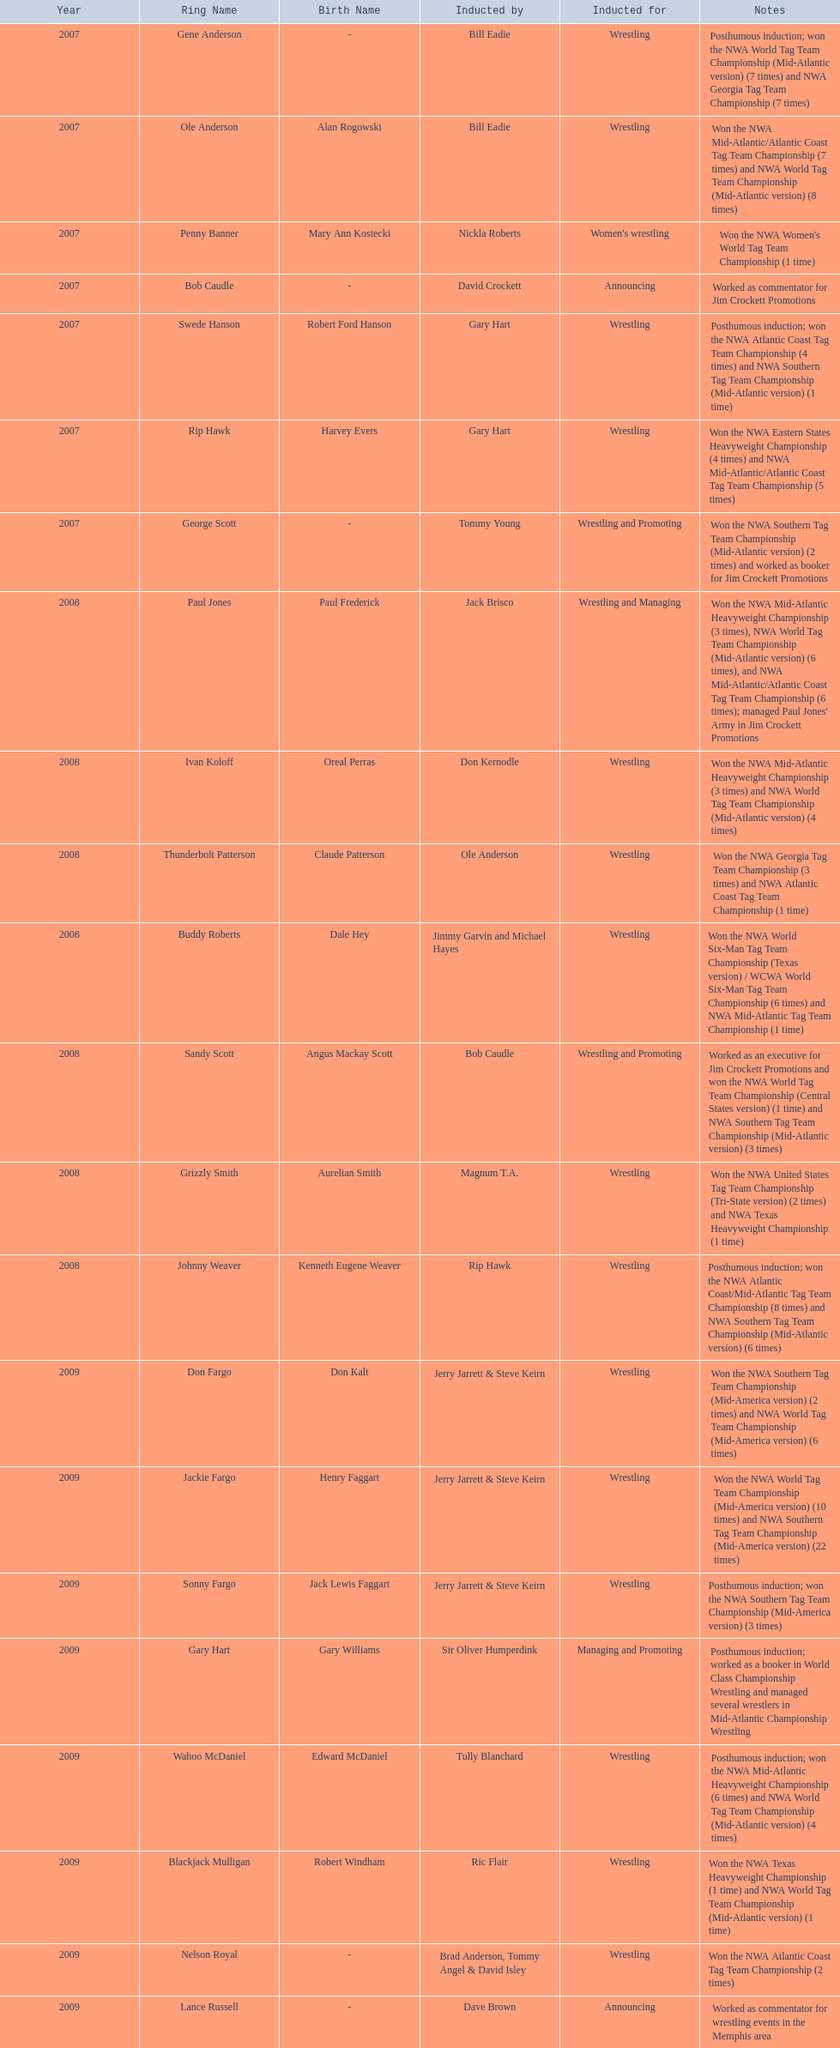What announcers were inducted? Bob Caudle, Lance Russell. What announcer was inducted in 2009? Lance Russell. 